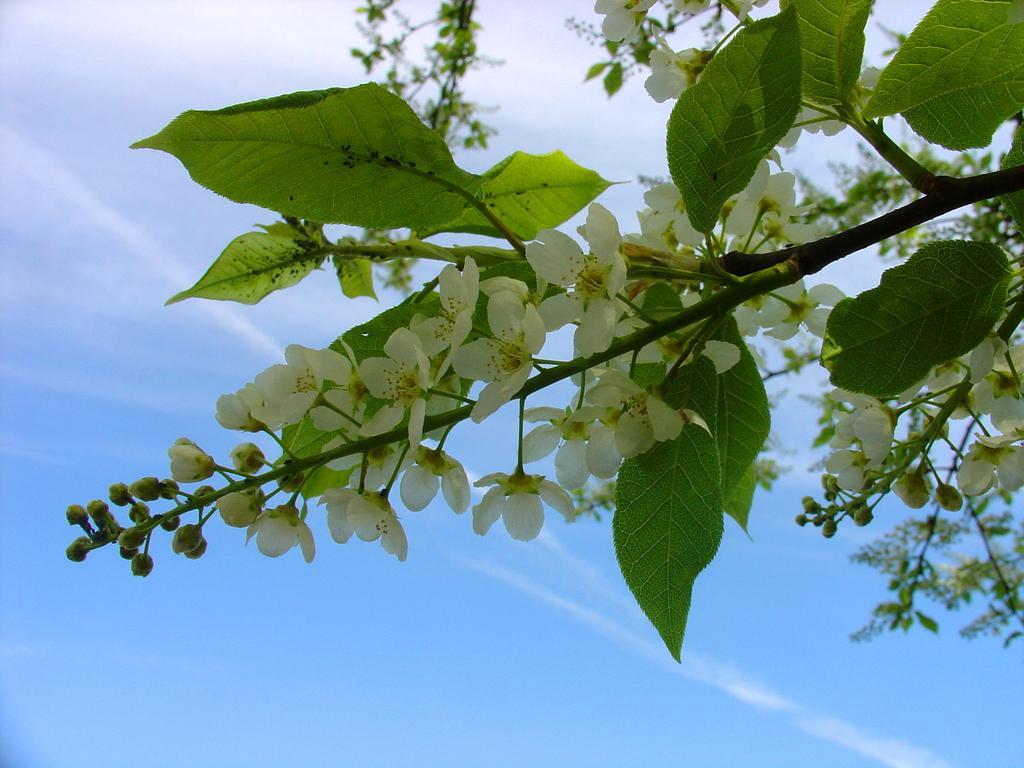In one or two sentences, can you explain what this image depicts? In the background we can see the sky. This picture is mainly highlighted with the green leaves, white flowers, buds and the stems. 